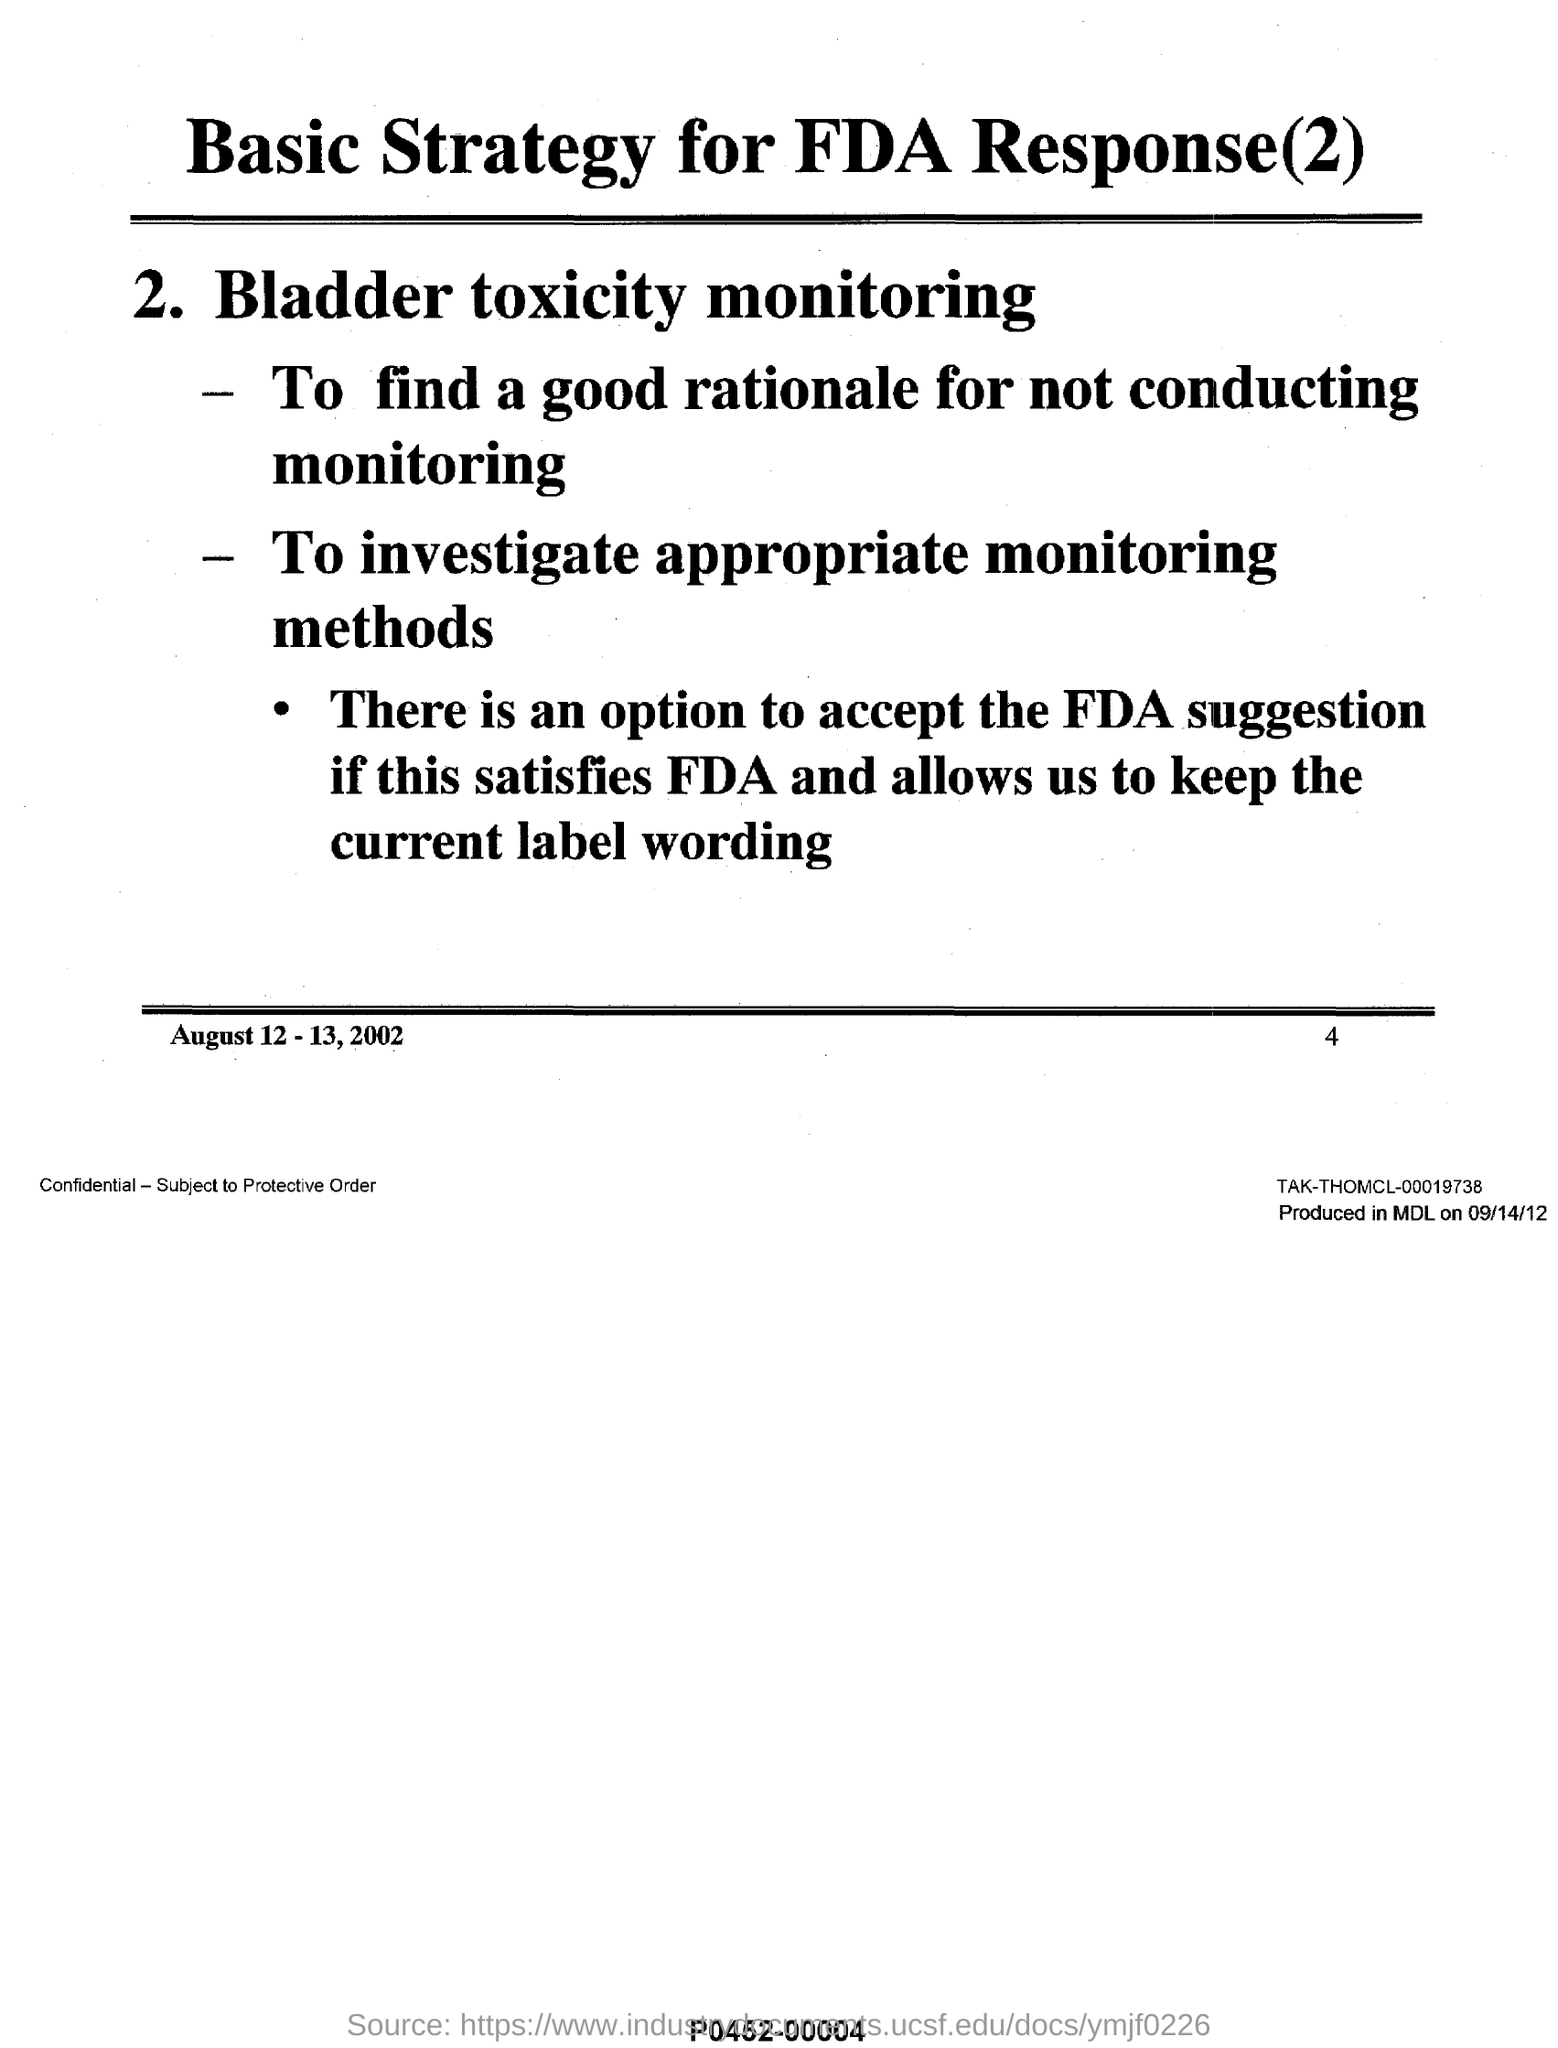Mention a couple of crucial points in this snapshot. The second purpose of bladder toxicity monitoring is to investigate appropriate monitoring methods to ensure the safe and effective use of bladder toxicity in the management of diseases. The second strategy for FDA response is bladder toxicity monitoring. 